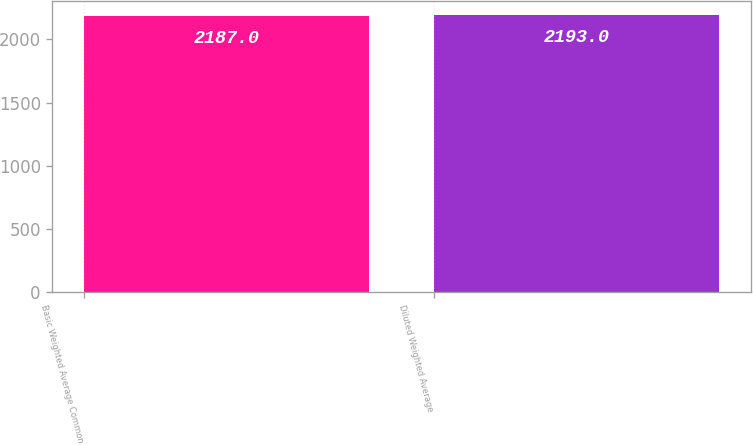<chart> <loc_0><loc_0><loc_500><loc_500><bar_chart><fcel>Basic Weighted Average Common<fcel>Diluted Weighted Average<nl><fcel>2187<fcel>2193<nl></chart> 